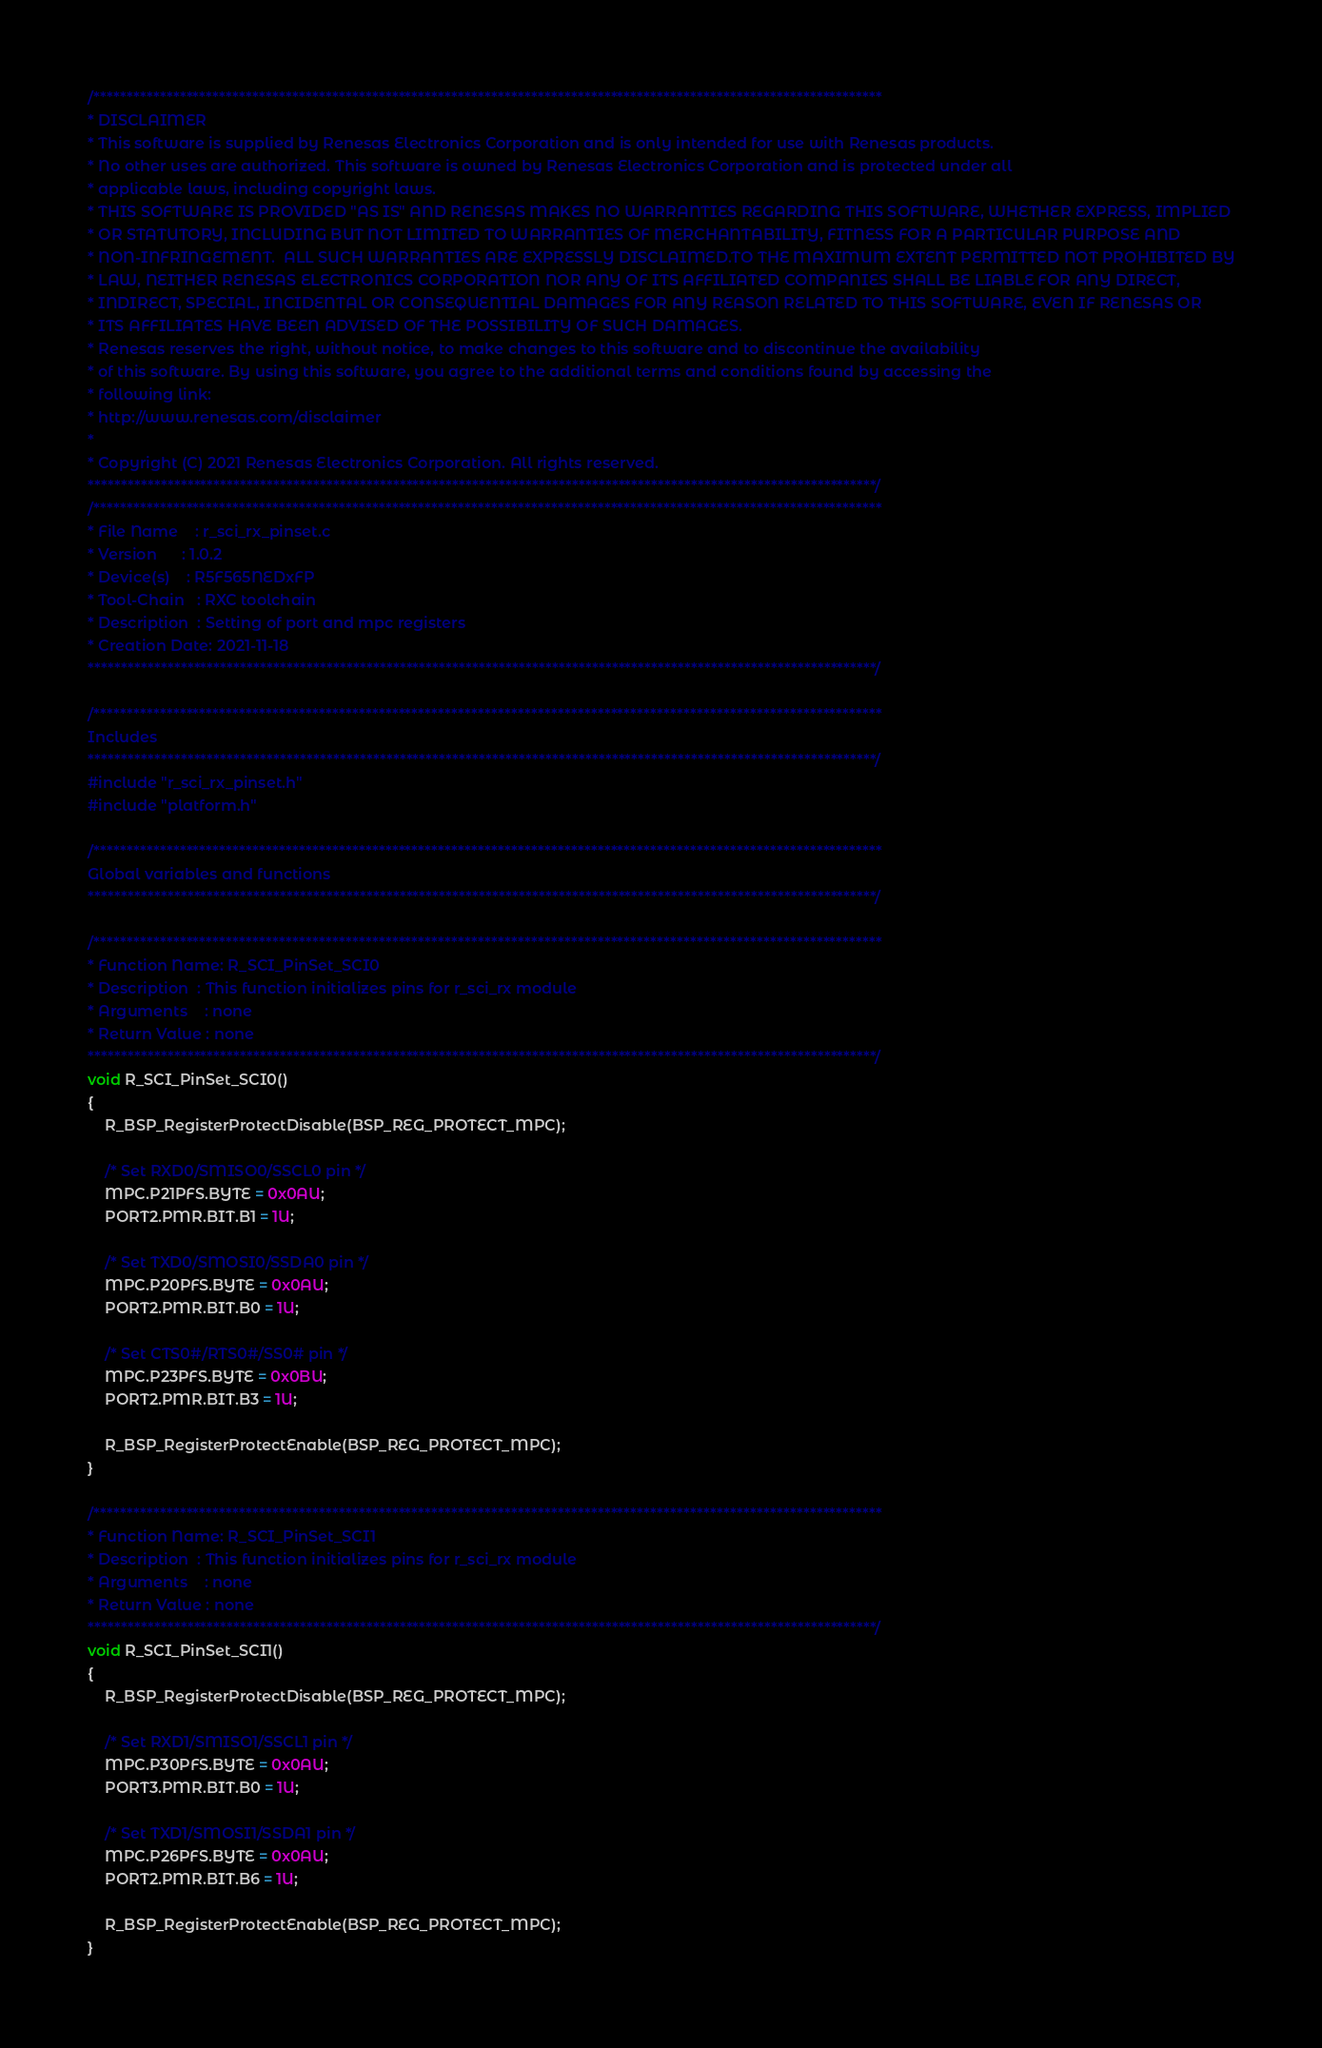<code> <loc_0><loc_0><loc_500><loc_500><_C_>/***********************************************************************************************************************
* DISCLAIMER
* This software is supplied by Renesas Electronics Corporation and is only intended for use with Renesas products.
* No other uses are authorized. This software is owned by Renesas Electronics Corporation and is protected under all
* applicable laws, including copyright laws. 
* THIS SOFTWARE IS PROVIDED "AS IS" AND RENESAS MAKES NO WARRANTIES REGARDING THIS SOFTWARE, WHETHER EXPRESS, IMPLIED
* OR STATUTORY, INCLUDING BUT NOT LIMITED TO WARRANTIES OF MERCHANTABILITY, FITNESS FOR A PARTICULAR PURPOSE AND
* NON-INFRINGEMENT.  ALL SUCH WARRANTIES ARE EXPRESSLY DISCLAIMED.TO THE MAXIMUM EXTENT PERMITTED NOT PROHIBITED BY
* LAW, NEITHER RENESAS ELECTRONICS CORPORATION NOR ANY OF ITS AFFILIATED COMPANIES SHALL BE LIABLE FOR ANY DIRECT,
* INDIRECT, SPECIAL, INCIDENTAL OR CONSEQUENTIAL DAMAGES FOR ANY REASON RELATED TO THIS SOFTWARE, EVEN IF RENESAS OR
* ITS AFFILIATES HAVE BEEN ADVISED OF THE POSSIBILITY OF SUCH DAMAGES.
* Renesas reserves the right, without notice, to make changes to this software and to discontinue the availability 
* of this software. By using this software, you agree to the additional terms and conditions found by accessing the 
* following link:
* http://www.renesas.com/disclaimer
*
* Copyright (C) 2021 Renesas Electronics Corporation. All rights reserved.
***********************************************************************************************************************/
/***********************************************************************************************************************
* File Name    : r_sci_rx_pinset.c
* Version      : 1.0.2
* Device(s)    : R5F565NEDxFP
* Tool-Chain   : RXC toolchain
* Description  : Setting of port and mpc registers
* Creation Date: 2021-11-18
***********************************************************************************************************************/

/***********************************************************************************************************************
Includes
***********************************************************************************************************************/
#include "r_sci_rx_pinset.h"
#include "platform.h"

/***********************************************************************************************************************
Global variables and functions
***********************************************************************************************************************/

/***********************************************************************************************************************
* Function Name: R_SCI_PinSet_SCI0
* Description  : This function initializes pins for r_sci_rx module
* Arguments    : none
* Return Value : none
***********************************************************************************************************************/
void R_SCI_PinSet_SCI0()
{
    R_BSP_RegisterProtectDisable(BSP_REG_PROTECT_MPC);

    /* Set RXD0/SMISO0/SSCL0 pin */
    MPC.P21PFS.BYTE = 0x0AU;
    PORT2.PMR.BIT.B1 = 1U;

    /* Set TXD0/SMOSI0/SSDA0 pin */
    MPC.P20PFS.BYTE = 0x0AU;
    PORT2.PMR.BIT.B0 = 1U;

    /* Set CTS0#/RTS0#/SS0# pin */
    MPC.P23PFS.BYTE = 0x0BU;
    PORT2.PMR.BIT.B3 = 1U;

    R_BSP_RegisterProtectEnable(BSP_REG_PROTECT_MPC);
}

/***********************************************************************************************************************
* Function Name: R_SCI_PinSet_SCI1
* Description  : This function initializes pins for r_sci_rx module
* Arguments    : none
* Return Value : none
***********************************************************************************************************************/
void R_SCI_PinSet_SCI1()
{
    R_BSP_RegisterProtectDisable(BSP_REG_PROTECT_MPC);

    /* Set RXD1/SMISO1/SSCL1 pin */
    MPC.P30PFS.BYTE = 0x0AU;
    PORT3.PMR.BIT.B0 = 1U;

    /* Set TXD1/SMOSI1/SSDA1 pin */
    MPC.P26PFS.BYTE = 0x0AU;
    PORT2.PMR.BIT.B6 = 1U;

    R_BSP_RegisterProtectEnable(BSP_REG_PROTECT_MPC);
}

</code> 